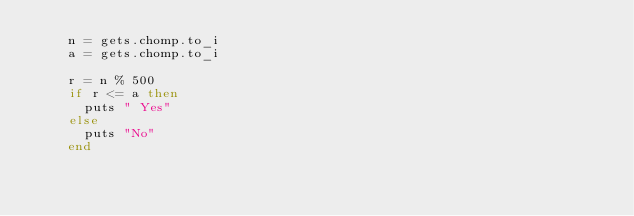<code> <loc_0><loc_0><loc_500><loc_500><_Ruby_>    n = gets.chomp.to_i
    a = gets.chomp.to_i
     
    r = n % 500
    if r <= a then
      puts " Yes"
    else
      puts "No"
    end</code> 